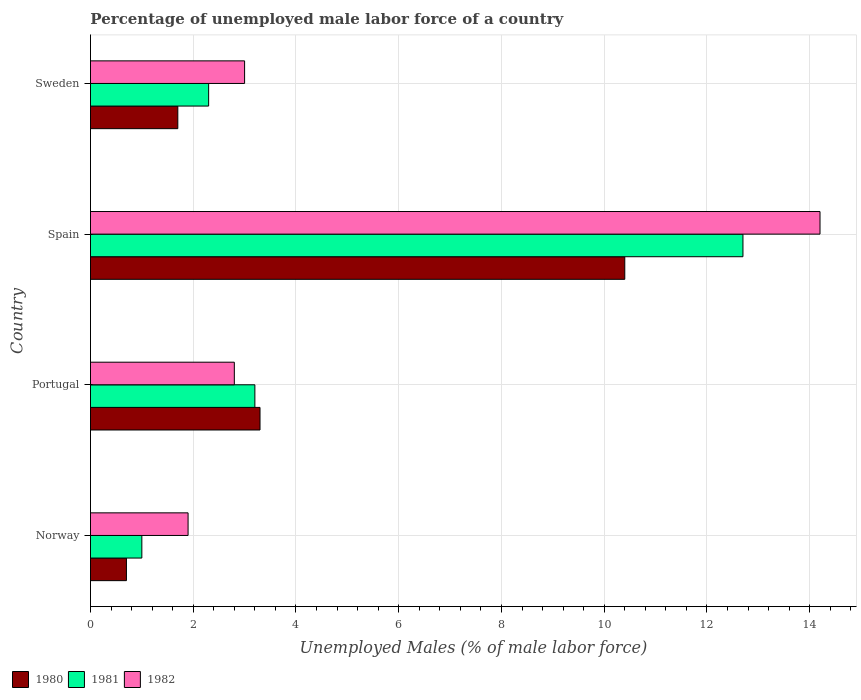How many different coloured bars are there?
Your answer should be compact. 3. How many bars are there on the 2nd tick from the bottom?
Keep it short and to the point. 3. What is the percentage of unemployed male labor force in 1981 in Spain?
Offer a terse response. 12.7. Across all countries, what is the maximum percentage of unemployed male labor force in 1980?
Provide a short and direct response. 10.4. Across all countries, what is the minimum percentage of unemployed male labor force in 1981?
Keep it short and to the point. 1. In which country was the percentage of unemployed male labor force in 1980 maximum?
Offer a very short reply. Spain. In which country was the percentage of unemployed male labor force in 1982 minimum?
Give a very brief answer. Norway. What is the total percentage of unemployed male labor force in 1981 in the graph?
Your response must be concise. 19.2. What is the difference between the percentage of unemployed male labor force in 1982 in Portugal and that in Sweden?
Ensure brevity in your answer.  -0.2. What is the difference between the percentage of unemployed male labor force in 1981 in Spain and the percentage of unemployed male labor force in 1982 in Sweden?
Ensure brevity in your answer.  9.7. What is the average percentage of unemployed male labor force in 1981 per country?
Give a very brief answer. 4.8. What is the difference between the percentage of unemployed male labor force in 1982 and percentage of unemployed male labor force in 1980 in Sweden?
Ensure brevity in your answer.  1.3. What is the ratio of the percentage of unemployed male labor force in 1980 in Norway to that in Sweden?
Offer a very short reply. 0.41. Is the percentage of unemployed male labor force in 1982 in Norway less than that in Portugal?
Your answer should be very brief. Yes. Is the difference between the percentage of unemployed male labor force in 1982 in Norway and Sweden greater than the difference between the percentage of unemployed male labor force in 1980 in Norway and Sweden?
Ensure brevity in your answer.  No. What is the difference between the highest and the second highest percentage of unemployed male labor force in 1982?
Give a very brief answer. 11.2. What is the difference between the highest and the lowest percentage of unemployed male labor force in 1981?
Provide a short and direct response. 11.7. In how many countries, is the percentage of unemployed male labor force in 1981 greater than the average percentage of unemployed male labor force in 1981 taken over all countries?
Give a very brief answer. 1. Is the sum of the percentage of unemployed male labor force in 1982 in Portugal and Sweden greater than the maximum percentage of unemployed male labor force in 1981 across all countries?
Keep it short and to the point. No. What does the 1st bar from the top in Sweden represents?
Offer a terse response. 1982. Are the values on the major ticks of X-axis written in scientific E-notation?
Provide a succinct answer. No. Where does the legend appear in the graph?
Your response must be concise. Bottom left. How many legend labels are there?
Offer a very short reply. 3. How are the legend labels stacked?
Provide a succinct answer. Horizontal. What is the title of the graph?
Your answer should be very brief. Percentage of unemployed male labor force of a country. Does "1975" appear as one of the legend labels in the graph?
Keep it short and to the point. No. What is the label or title of the X-axis?
Ensure brevity in your answer.  Unemployed Males (% of male labor force). What is the label or title of the Y-axis?
Offer a very short reply. Country. What is the Unemployed Males (% of male labor force) of 1980 in Norway?
Your answer should be compact. 0.7. What is the Unemployed Males (% of male labor force) of 1981 in Norway?
Offer a very short reply. 1. What is the Unemployed Males (% of male labor force) of 1982 in Norway?
Provide a short and direct response. 1.9. What is the Unemployed Males (% of male labor force) in 1980 in Portugal?
Offer a very short reply. 3.3. What is the Unemployed Males (% of male labor force) of 1981 in Portugal?
Your answer should be compact. 3.2. What is the Unemployed Males (% of male labor force) of 1982 in Portugal?
Make the answer very short. 2.8. What is the Unemployed Males (% of male labor force) of 1980 in Spain?
Offer a very short reply. 10.4. What is the Unemployed Males (% of male labor force) of 1981 in Spain?
Your answer should be very brief. 12.7. What is the Unemployed Males (% of male labor force) of 1982 in Spain?
Provide a succinct answer. 14.2. What is the Unemployed Males (% of male labor force) in 1980 in Sweden?
Offer a very short reply. 1.7. What is the Unemployed Males (% of male labor force) in 1981 in Sweden?
Ensure brevity in your answer.  2.3. Across all countries, what is the maximum Unemployed Males (% of male labor force) in 1980?
Provide a succinct answer. 10.4. Across all countries, what is the maximum Unemployed Males (% of male labor force) of 1981?
Ensure brevity in your answer.  12.7. Across all countries, what is the maximum Unemployed Males (% of male labor force) of 1982?
Offer a terse response. 14.2. Across all countries, what is the minimum Unemployed Males (% of male labor force) in 1980?
Provide a succinct answer. 0.7. Across all countries, what is the minimum Unemployed Males (% of male labor force) in 1981?
Give a very brief answer. 1. Across all countries, what is the minimum Unemployed Males (% of male labor force) of 1982?
Provide a short and direct response. 1.9. What is the total Unemployed Males (% of male labor force) of 1982 in the graph?
Your answer should be very brief. 21.9. What is the difference between the Unemployed Males (% of male labor force) in 1981 in Norway and that in Portugal?
Offer a terse response. -2.2. What is the difference between the Unemployed Males (% of male labor force) of 1980 in Norway and that in Sweden?
Make the answer very short. -1. What is the difference between the Unemployed Males (% of male labor force) of 1980 in Portugal and that in Sweden?
Give a very brief answer. 1.6. What is the difference between the Unemployed Males (% of male labor force) of 1980 in Spain and that in Sweden?
Your answer should be compact. 8.7. What is the difference between the Unemployed Males (% of male labor force) in 1981 in Spain and that in Sweden?
Make the answer very short. 10.4. What is the difference between the Unemployed Males (% of male labor force) of 1982 in Spain and that in Sweden?
Provide a succinct answer. 11.2. What is the difference between the Unemployed Males (% of male labor force) of 1980 in Norway and the Unemployed Males (% of male labor force) of 1981 in Portugal?
Offer a very short reply. -2.5. What is the difference between the Unemployed Males (% of male labor force) in 1980 in Norway and the Unemployed Males (% of male labor force) in 1982 in Portugal?
Make the answer very short. -2.1. What is the difference between the Unemployed Males (% of male labor force) of 1981 in Norway and the Unemployed Males (% of male labor force) of 1982 in Portugal?
Give a very brief answer. -1.8. What is the difference between the Unemployed Males (% of male labor force) of 1981 in Norway and the Unemployed Males (% of male labor force) of 1982 in Spain?
Make the answer very short. -13.2. What is the difference between the Unemployed Males (% of male labor force) in 1980 in Norway and the Unemployed Males (% of male labor force) in 1981 in Sweden?
Give a very brief answer. -1.6. What is the difference between the Unemployed Males (% of male labor force) in 1981 in Norway and the Unemployed Males (% of male labor force) in 1982 in Sweden?
Provide a succinct answer. -2. What is the difference between the Unemployed Males (% of male labor force) of 1980 in Portugal and the Unemployed Males (% of male labor force) of 1981 in Spain?
Keep it short and to the point. -9.4. What is the difference between the Unemployed Males (% of male labor force) in 1980 in Portugal and the Unemployed Males (% of male labor force) in 1982 in Spain?
Give a very brief answer. -10.9. What is the difference between the Unemployed Males (% of male labor force) of 1981 in Portugal and the Unemployed Males (% of male labor force) of 1982 in Spain?
Give a very brief answer. -11. What is the difference between the Unemployed Males (% of male labor force) of 1980 in Spain and the Unemployed Males (% of male labor force) of 1981 in Sweden?
Your response must be concise. 8.1. What is the difference between the Unemployed Males (% of male labor force) in 1980 in Spain and the Unemployed Males (% of male labor force) in 1982 in Sweden?
Your answer should be compact. 7.4. What is the average Unemployed Males (% of male labor force) in 1980 per country?
Keep it short and to the point. 4.03. What is the average Unemployed Males (% of male labor force) in 1981 per country?
Your response must be concise. 4.8. What is the average Unemployed Males (% of male labor force) in 1982 per country?
Keep it short and to the point. 5.47. What is the difference between the Unemployed Males (% of male labor force) of 1980 and Unemployed Males (% of male labor force) of 1981 in Norway?
Your answer should be compact. -0.3. What is the difference between the Unemployed Males (% of male labor force) in 1980 and Unemployed Males (% of male labor force) in 1982 in Norway?
Keep it short and to the point. -1.2. What is the difference between the Unemployed Males (% of male labor force) of 1981 and Unemployed Males (% of male labor force) of 1982 in Norway?
Ensure brevity in your answer.  -0.9. What is the difference between the Unemployed Males (% of male labor force) in 1980 and Unemployed Males (% of male labor force) in 1982 in Portugal?
Your answer should be compact. 0.5. What is the difference between the Unemployed Males (% of male labor force) of 1981 and Unemployed Males (% of male labor force) of 1982 in Portugal?
Provide a succinct answer. 0.4. What is the difference between the Unemployed Males (% of male labor force) in 1980 and Unemployed Males (% of male labor force) in 1982 in Spain?
Give a very brief answer. -3.8. What is the difference between the Unemployed Males (% of male labor force) in 1980 and Unemployed Males (% of male labor force) in 1981 in Sweden?
Your answer should be very brief. -0.6. What is the difference between the Unemployed Males (% of male labor force) of 1980 and Unemployed Males (% of male labor force) of 1982 in Sweden?
Your answer should be very brief. -1.3. What is the ratio of the Unemployed Males (% of male labor force) in 1980 in Norway to that in Portugal?
Provide a short and direct response. 0.21. What is the ratio of the Unemployed Males (% of male labor force) in 1981 in Norway to that in Portugal?
Provide a short and direct response. 0.31. What is the ratio of the Unemployed Males (% of male labor force) in 1982 in Norway to that in Portugal?
Provide a succinct answer. 0.68. What is the ratio of the Unemployed Males (% of male labor force) of 1980 in Norway to that in Spain?
Provide a short and direct response. 0.07. What is the ratio of the Unemployed Males (% of male labor force) of 1981 in Norway to that in Spain?
Provide a short and direct response. 0.08. What is the ratio of the Unemployed Males (% of male labor force) of 1982 in Norway to that in Spain?
Offer a terse response. 0.13. What is the ratio of the Unemployed Males (% of male labor force) in 1980 in Norway to that in Sweden?
Provide a short and direct response. 0.41. What is the ratio of the Unemployed Males (% of male labor force) of 1981 in Norway to that in Sweden?
Ensure brevity in your answer.  0.43. What is the ratio of the Unemployed Males (% of male labor force) in 1982 in Norway to that in Sweden?
Offer a terse response. 0.63. What is the ratio of the Unemployed Males (% of male labor force) in 1980 in Portugal to that in Spain?
Make the answer very short. 0.32. What is the ratio of the Unemployed Males (% of male labor force) in 1981 in Portugal to that in Spain?
Your answer should be compact. 0.25. What is the ratio of the Unemployed Males (% of male labor force) of 1982 in Portugal to that in Spain?
Provide a succinct answer. 0.2. What is the ratio of the Unemployed Males (% of male labor force) of 1980 in Portugal to that in Sweden?
Make the answer very short. 1.94. What is the ratio of the Unemployed Males (% of male labor force) of 1981 in Portugal to that in Sweden?
Your answer should be very brief. 1.39. What is the ratio of the Unemployed Males (% of male labor force) of 1982 in Portugal to that in Sweden?
Offer a terse response. 0.93. What is the ratio of the Unemployed Males (% of male labor force) in 1980 in Spain to that in Sweden?
Provide a short and direct response. 6.12. What is the ratio of the Unemployed Males (% of male labor force) in 1981 in Spain to that in Sweden?
Provide a succinct answer. 5.52. What is the ratio of the Unemployed Males (% of male labor force) of 1982 in Spain to that in Sweden?
Offer a terse response. 4.73. What is the difference between the highest and the second highest Unemployed Males (% of male labor force) of 1982?
Your answer should be compact. 11.2. What is the difference between the highest and the lowest Unemployed Males (% of male labor force) of 1980?
Provide a short and direct response. 9.7. What is the difference between the highest and the lowest Unemployed Males (% of male labor force) in 1982?
Provide a succinct answer. 12.3. 